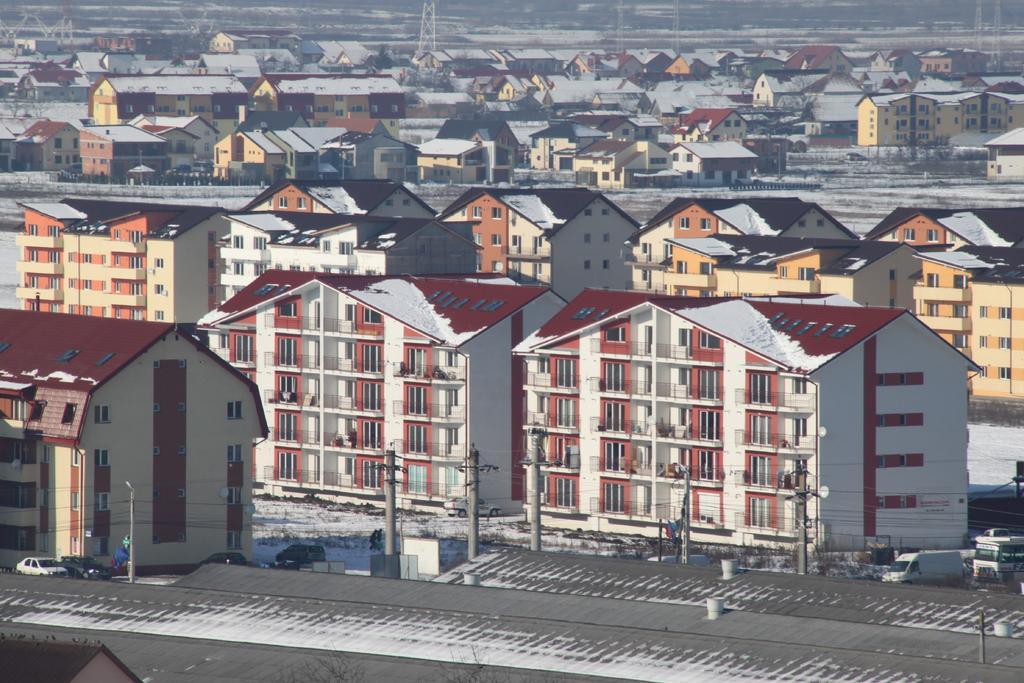In one or two sentences, can you explain what this image depicts? In the picture there are plenty of houses and in the front line there are two cars parked in front of the building. 